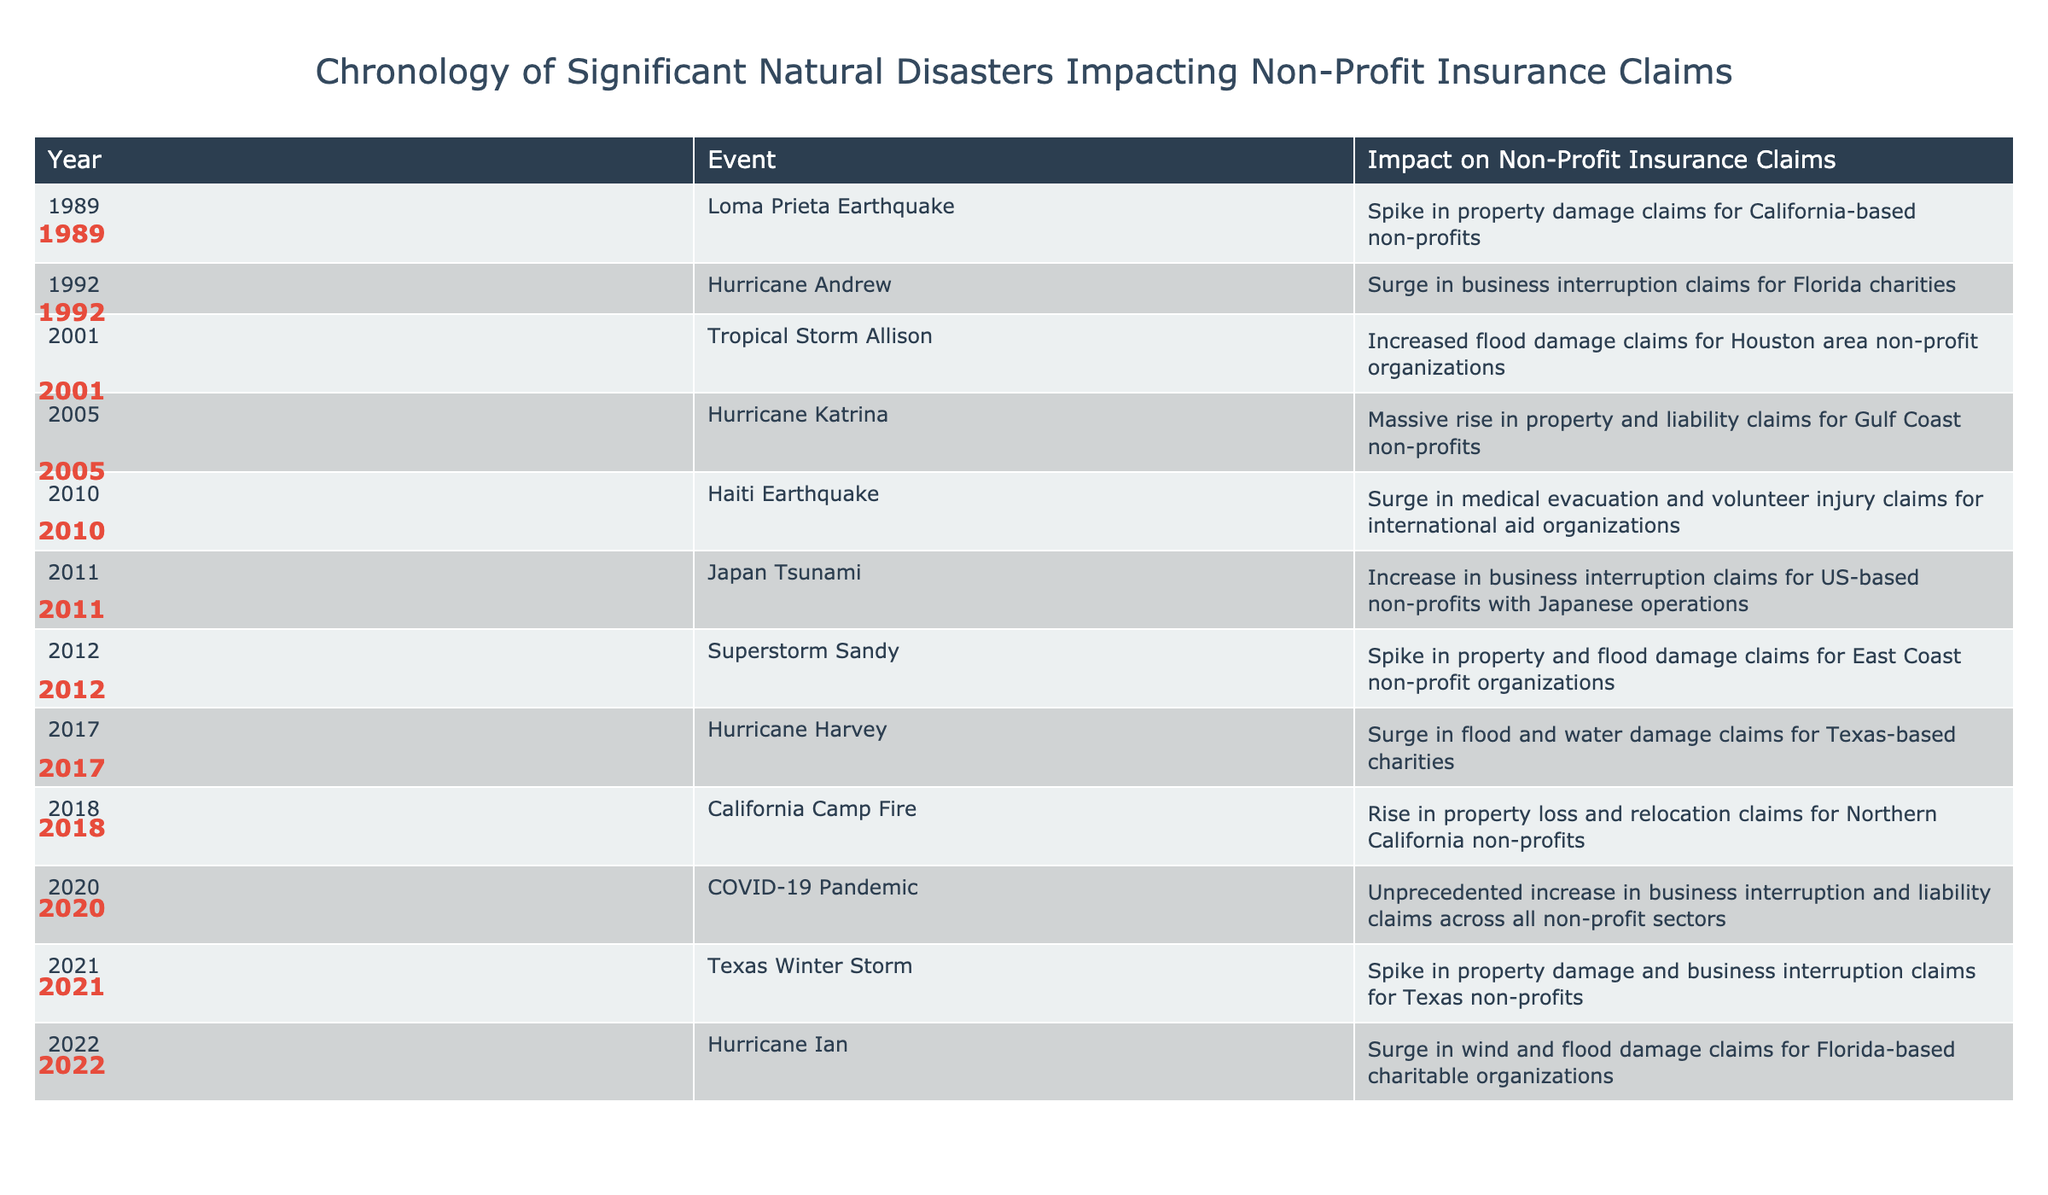What significant natural disaster occurred in 2005 and what was its impact on non-profit insurance claims? In 2005, Hurricane Katrina occurred, leading to a massive rise in property and liability claims for Gulf Coast non-profits.
Answer: Hurricane Katrina, massive rise in property and liability claims Which disaster in 2012 prompted a spike in property and flood damage claims for non-profit organizations? The disaster in 2012 that prompted a spike in property and flood damage claims for non-profit organizations was Superstorm Sandy.
Answer: Superstorm Sandy Did Hurricane Andrew in 1992 result in an increase in medical evacuation claims? No, Hurricane Andrew did not result in an increase in medical evacuation claims; instead, it caused a surge in business interruption claims for Florida charities.
Answer: No What was the general trend of insurance claims following natural disasters from 1989 to 2022? The general trend indicates that all listed natural disasters resulted in significant increases in various types of insurance claims, particularly for property and business interruption.
Answer: Increase in insurance claims Which disaster caused the highest impact on international aid organizations in terms of medical evacuation and volunteer injury claims? The Haiti Earthquake in 2010 caused the highest impact on international aid organizations, leading to a surge in medical evacuation and volunteer injury claims.
Answer: Haiti Earthquake, 2010 How many significant natural disasters listed in the table resulted in an increase in flood damage claims? Five significant natural disasters resulted in an increase in flood damage claims: Tropical Storm Allison (2001), Hurricane Katrina (2005), Superstorm Sandy (2012), Hurricane Harvey (2017), and Hurricane Ian (2022).
Answer: Five disasters What is the timeframe during which non-profits faced unprecedented claims due to the COVID-19 pandemic? The COVID-19 pandemic caused unprecedented claims across all non-profit sectors in 2020.
Answer: 2020 Which years had the most recent disasters, and what were their impacts? The most recent disasters occurred in 2021 (Texas Winter Storm, spike in property damage and business interruption claims) and 2022 (Hurricane Ian, surge in wind and flood damage claims for Florida-based charities).
Answer: 2021 and 2022 